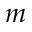<formula> <loc_0><loc_0><loc_500><loc_500>m</formula> 